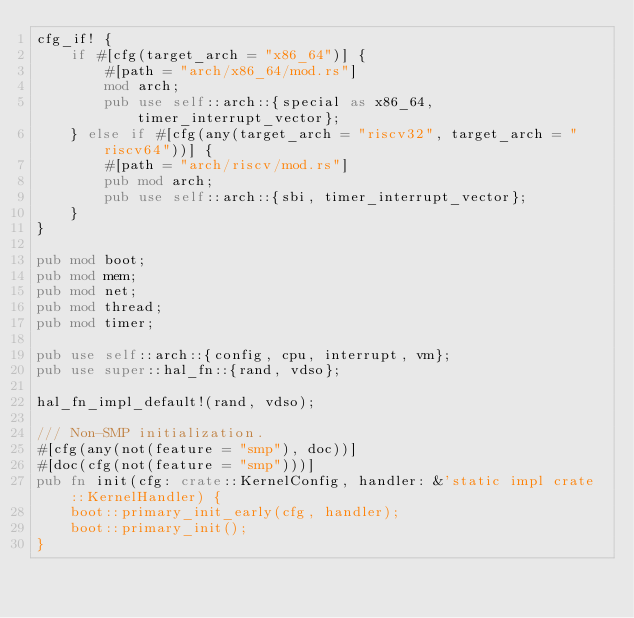<code> <loc_0><loc_0><loc_500><loc_500><_Rust_>cfg_if! {
    if #[cfg(target_arch = "x86_64")] {
        #[path = "arch/x86_64/mod.rs"]
        mod arch;
        pub use self::arch::{special as x86_64, timer_interrupt_vector};
    } else if #[cfg(any(target_arch = "riscv32", target_arch = "riscv64"))] {
        #[path = "arch/riscv/mod.rs"]
        pub mod arch;
        pub use self::arch::{sbi, timer_interrupt_vector};
    }
}

pub mod boot;
pub mod mem;
pub mod net;
pub mod thread;
pub mod timer;

pub use self::arch::{config, cpu, interrupt, vm};
pub use super::hal_fn::{rand, vdso};

hal_fn_impl_default!(rand, vdso);

/// Non-SMP initialization.
#[cfg(any(not(feature = "smp"), doc))]
#[doc(cfg(not(feature = "smp")))]
pub fn init(cfg: crate::KernelConfig, handler: &'static impl crate::KernelHandler) {
    boot::primary_init_early(cfg, handler);
    boot::primary_init();
}
</code> 